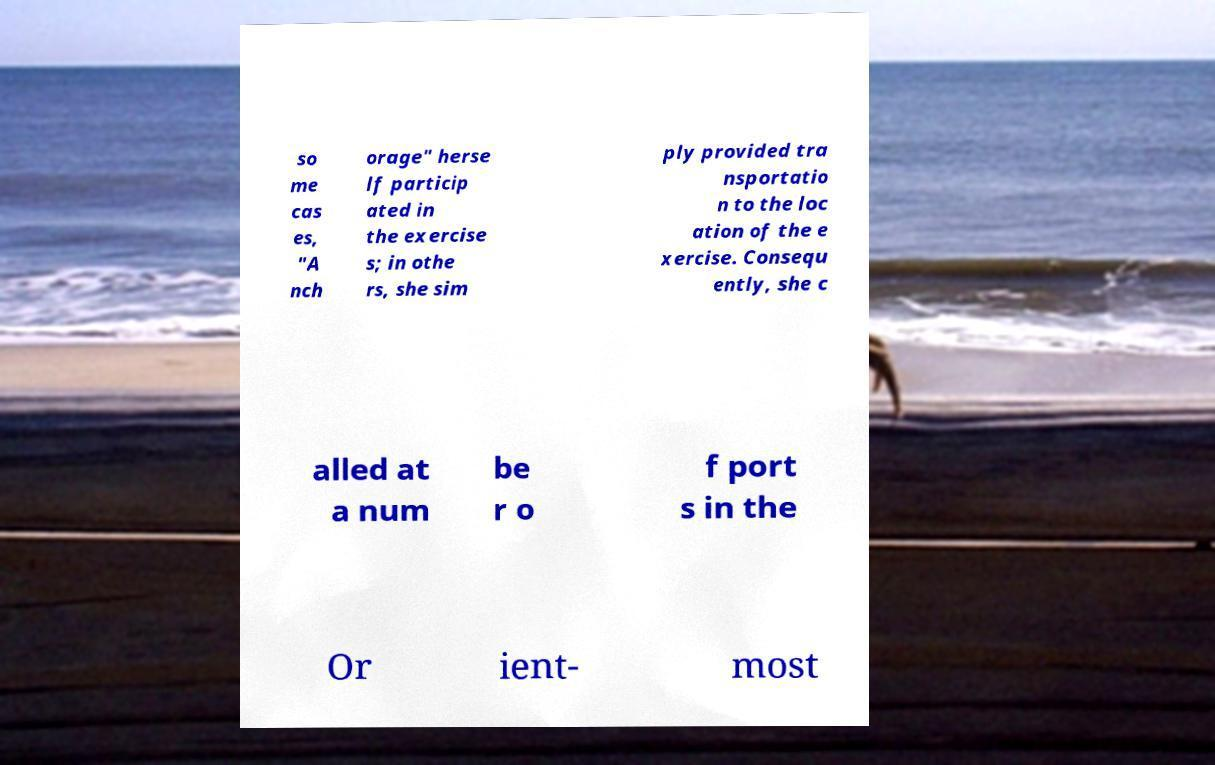There's text embedded in this image that I need extracted. Can you transcribe it verbatim? so me cas es, "A nch orage" herse lf particip ated in the exercise s; in othe rs, she sim ply provided tra nsportatio n to the loc ation of the e xercise. Consequ ently, she c alled at a num be r o f port s in the Or ient- most 